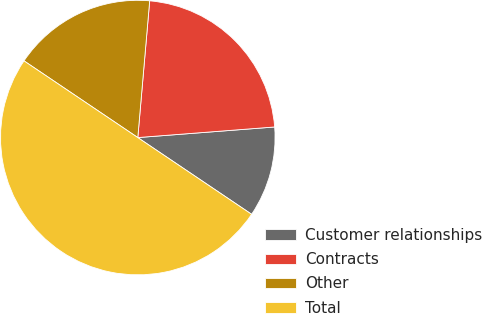Convert chart to OTSL. <chart><loc_0><loc_0><loc_500><loc_500><pie_chart><fcel>Customer relationships<fcel>Contracts<fcel>Other<fcel>Total<nl><fcel>10.67%<fcel>22.39%<fcel>16.94%<fcel>50.0%<nl></chart> 